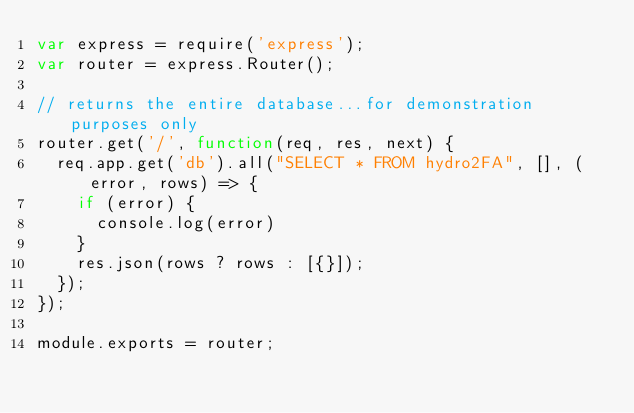<code> <loc_0><loc_0><loc_500><loc_500><_JavaScript_>var express = require('express');
var router = express.Router();

// returns the entire database...for demonstration purposes only
router.get('/', function(req, res, next) {
  req.app.get('db').all("SELECT * FROM hydro2FA", [], (error, rows) => {
    if (error) {
      console.log(error)
    }
    res.json(rows ? rows : [{}]);
  });
});

module.exports = router;
</code> 